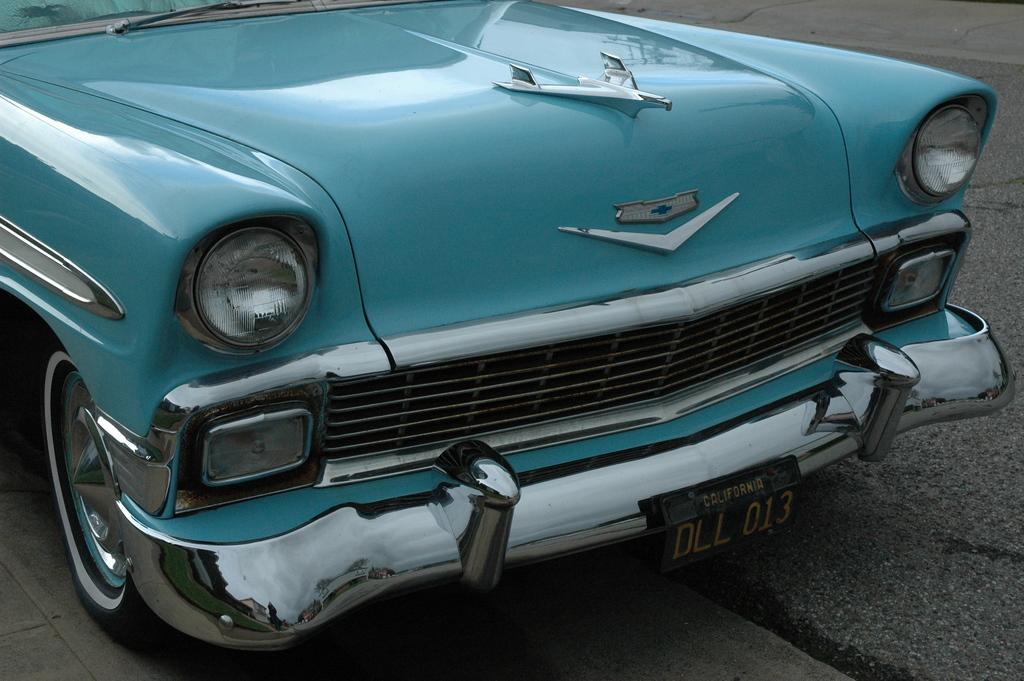How would you summarize this image in a sentence or two? In this image in the foreground there is one car on the road. 